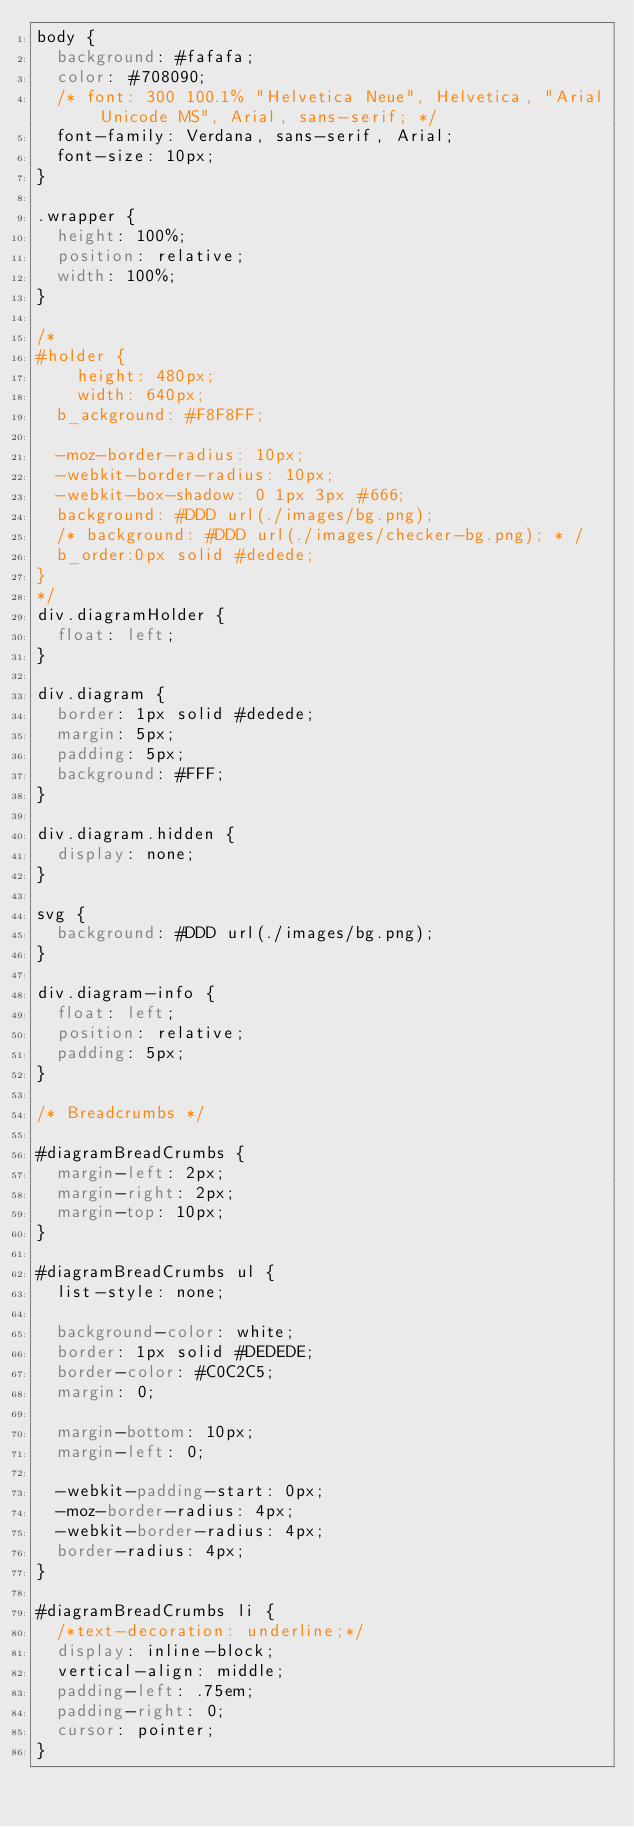Convert code to text. <code><loc_0><loc_0><loc_500><loc_500><_CSS_>body {
  background: #fafafa;
  color: #708090;
  /* font: 300 100.1% "Helvetica Neue", Helvetica, "Arial Unicode MS", Arial, sans-serif; */
  font-family: Verdana, sans-serif, Arial;
  font-size: 10px;
}

.wrapper {
  height: 100%;
  position: relative;
  width: 100%;
}

/*
#holder {
    height: 480px;
    width: 640px;
	b_ackground: #F8F8FF;

	-moz-border-radius: 10px;
	-webkit-border-radius: 10px;
	-webkit-box-shadow: 0 1px 3px #666;
	background: #DDD url(./images/bg.png);
	/* background: #DDD url(./images/checker-bg.png); * /
	b_order:0px solid #dedede;
}
*/
div.diagramHolder {
  float: left;
}

div.diagram {
  border: 1px solid #dedede;
  margin: 5px;
  padding: 5px;
  background: #FFF;
}

div.diagram.hidden {
  display: none;
}

svg {
  background: #DDD url(./images/bg.png);
}

div.diagram-info {
  float: left;
  position: relative;
  padding: 5px;
}

/* Breadcrumbs */

#diagramBreadCrumbs {
  margin-left: 2px;
  margin-right: 2px;
  margin-top: 10px;
}

#diagramBreadCrumbs ul {
  list-style: none;

  background-color: white;
  border: 1px solid #DEDEDE;
  border-color: #C0C2C5;
  margin: 0;

  margin-bottom: 10px;
  margin-left: 0;

  -webkit-padding-start: 0px;
  -moz-border-radius: 4px;
  -webkit-border-radius: 4px;
  border-radius: 4px;
}

#diagramBreadCrumbs li {
  /*text-decoration: underline;*/
  display: inline-block;
  vertical-align: middle;
  padding-left: .75em;
  padding-right: 0;
  cursor: pointer;
}
</code> 